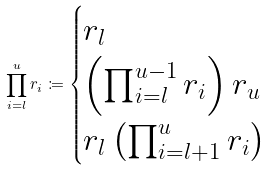Convert formula to latex. <formula><loc_0><loc_0><loc_500><loc_500>\prod _ { i = l } ^ { u } r _ { i } \coloneqq \begin{cases} r _ { l } & \\ \left ( \prod _ { i = l } ^ { u - 1 } r _ { i } \right ) r _ { u } & \\ r _ { l } \left ( \prod _ { i = l + 1 } ^ { u } r _ { i } \right ) & \end{cases}</formula> 